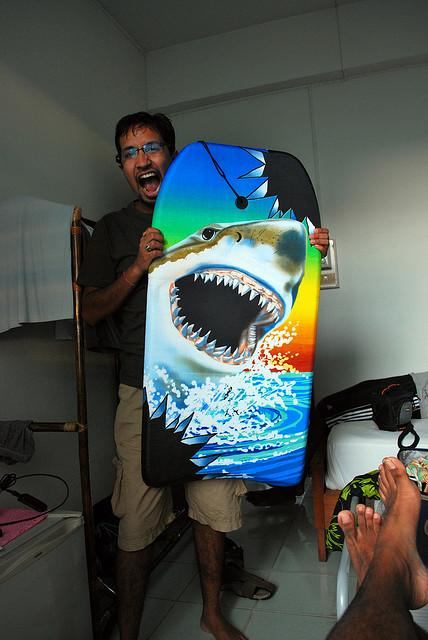What water sport is the object the man is holding used in? surfing 